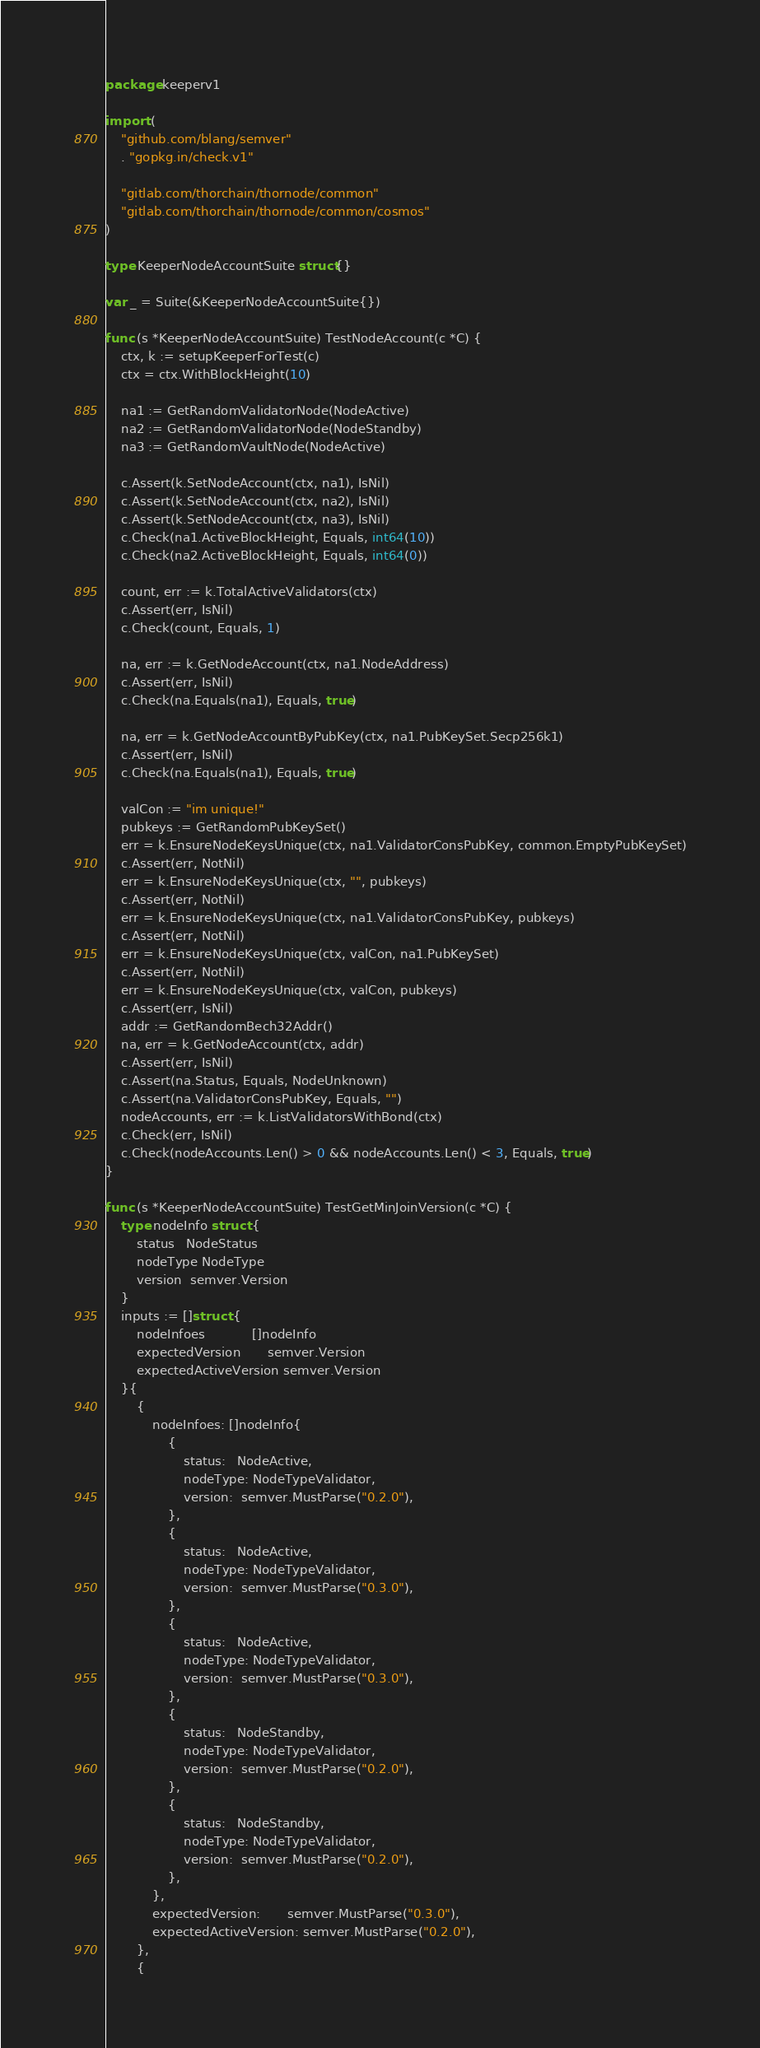Convert code to text. <code><loc_0><loc_0><loc_500><loc_500><_Go_>package keeperv1

import (
	"github.com/blang/semver"
	. "gopkg.in/check.v1"

	"gitlab.com/thorchain/thornode/common"
	"gitlab.com/thorchain/thornode/common/cosmos"
)

type KeeperNodeAccountSuite struct{}

var _ = Suite(&KeeperNodeAccountSuite{})

func (s *KeeperNodeAccountSuite) TestNodeAccount(c *C) {
	ctx, k := setupKeeperForTest(c)
	ctx = ctx.WithBlockHeight(10)

	na1 := GetRandomValidatorNode(NodeActive)
	na2 := GetRandomValidatorNode(NodeStandby)
	na3 := GetRandomVaultNode(NodeActive)

	c.Assert(k.SetNodeAccount(ctx, na1), IsNil)
	c.Assert(k.SetNodeAccount(ctx, na2), IsNil)
	c.Assert(k.SetNodeAccount(ctx, na3), IsNil)
	c.Check(na1.ActiveBlockHeight, Equals, int64(10))
	c.Check(na2.ActiveBlockHeight, Equals, int64(0))

	count, err := k.TotalActiveValidators(ctx)
	c.Assert(err, IsNil)
	c.Check(count, Equals, 1)

	na, err := k.GetNodeAccount(ctx, na1.NodeAddress)
	c.Assert(err, IsNil)
	c.Check(na.Equals(na1), Equals, true)

	na, err = k.GetNodeAccountByPubKey(ctx, na1.PubKeySet.Secp256k1)
	c.Assert(err, IsNil)
	c.Check(na.Equals(na1), Equals, true)

	valCon := "im unique!"
	pubkeys := GetRandomPubKeySet()
	err = k.EnsureNodeKeysUnique(ctx, na1.ValidatorConsPubKey, common.EmptyPubKeySet)
	c.Assert(err, NotNil)
	err = k.EnsureNodeKeysUnique(ctx, "", pubkeys)
	c.Assert(err, NotNil)
	err = k.EnsureNodeKeysUnique(ctx, na1.ValidatorConsPubKey, pubkeys)
	c.Assert(err, NotNil)
	err = k.EnsureNodeKeysUnique(ctx, valCon, na1.PubKeySet)
	c.Assert(err, NotNil)
	err = k.EnsureNodeKeysUnique(ctx, valCon, pubkeys)
	c.Assert(err, IsNil)
	addr := GetRandomBech32Addr()
	na, err = k.GetNodeAccount(ctx, addr)
	c.Assert(err, IsNil)
	c.Assert(na.Status, Equals, NodeUnknown)
	c.Assert(na.ValidatorConsPubKey, Equals, "")
	nodeAccounts, err := k.ListValidatorsWithBond(ctx)
	c.Check(err, IsNil)
	c.Check(nodeAccounts.Len() > 0 && nodeAccounts.Len() < 3, Equals, true)
}

func (s *KeeperNodeAccountSuite) TestGetMinJoinVersion(c *C) {
	type nodeInfo struct {
		status   NodeStatus
		nodeType NodeType
		version  semver.Version
	}
	inputs := []struct {
		nodeInfoes            []nodeInfo
		expectedVersion       semver.Version
		expectedActiveVersion semver.Version
	}{
		{
			nodeInfoes: []nodeInfo{
				{
					status:   NodeActive,
					nodeType: NodeTypeValidator,
					version:  semver.MustParse("0.2.0"),
				},
				{
					status:   NodeActive,
					nodeType: NodeTypeValidator,
					version:  semver.MustParse("0.3.0"),
				},
				{
					status:   NodeActive,
					nodeType: NodeTypeValidator,
					version:  semver.MustParse("0.3.0"),
				},
				{
					status:   NodeStandby,
					nodeType: NodeTypeValidator,
					version:  semver.MustParse("0.2.0"),
				},
				{
					status:   NodeStandby,
					nodeType: NodeTypeValidator,
					version:  semver.MustParse("0.2.0"),
				},
			},
			expectedVersion:       semver.MustParse("0.3.0"),
			expectedActiveVersion: semver.MustParse("0.2.0"),
		},
		{</code> 